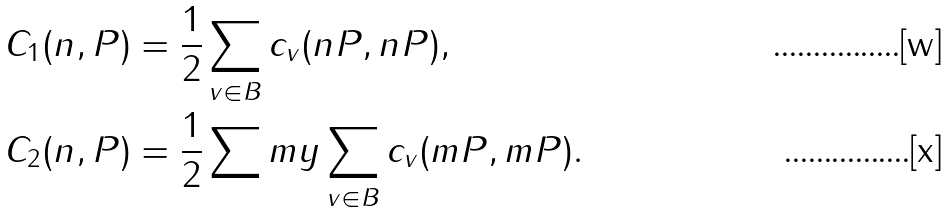Convert formula to latex. <formula><loc_0><loc_0><loc_500><loc_500>C _ { 1 } ( n , P ) & = \frac { 1 } { 2 } \sum _ { v \in B } c _ { v } ( n P , n P ) , \\ C _ { 2 } ( n , P ) & = \frac { 1 } { 2 } \sum m y \sum _ { v \in B } c _ { v } ( m P , m P ) .</formula> 